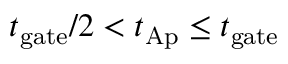<formula> <loc_0><loc_0><loc_500><loc_500>{ t _ { g a t e } } / { 2 } < t _ { A p } \leq t _ { g a t e }</formula> 